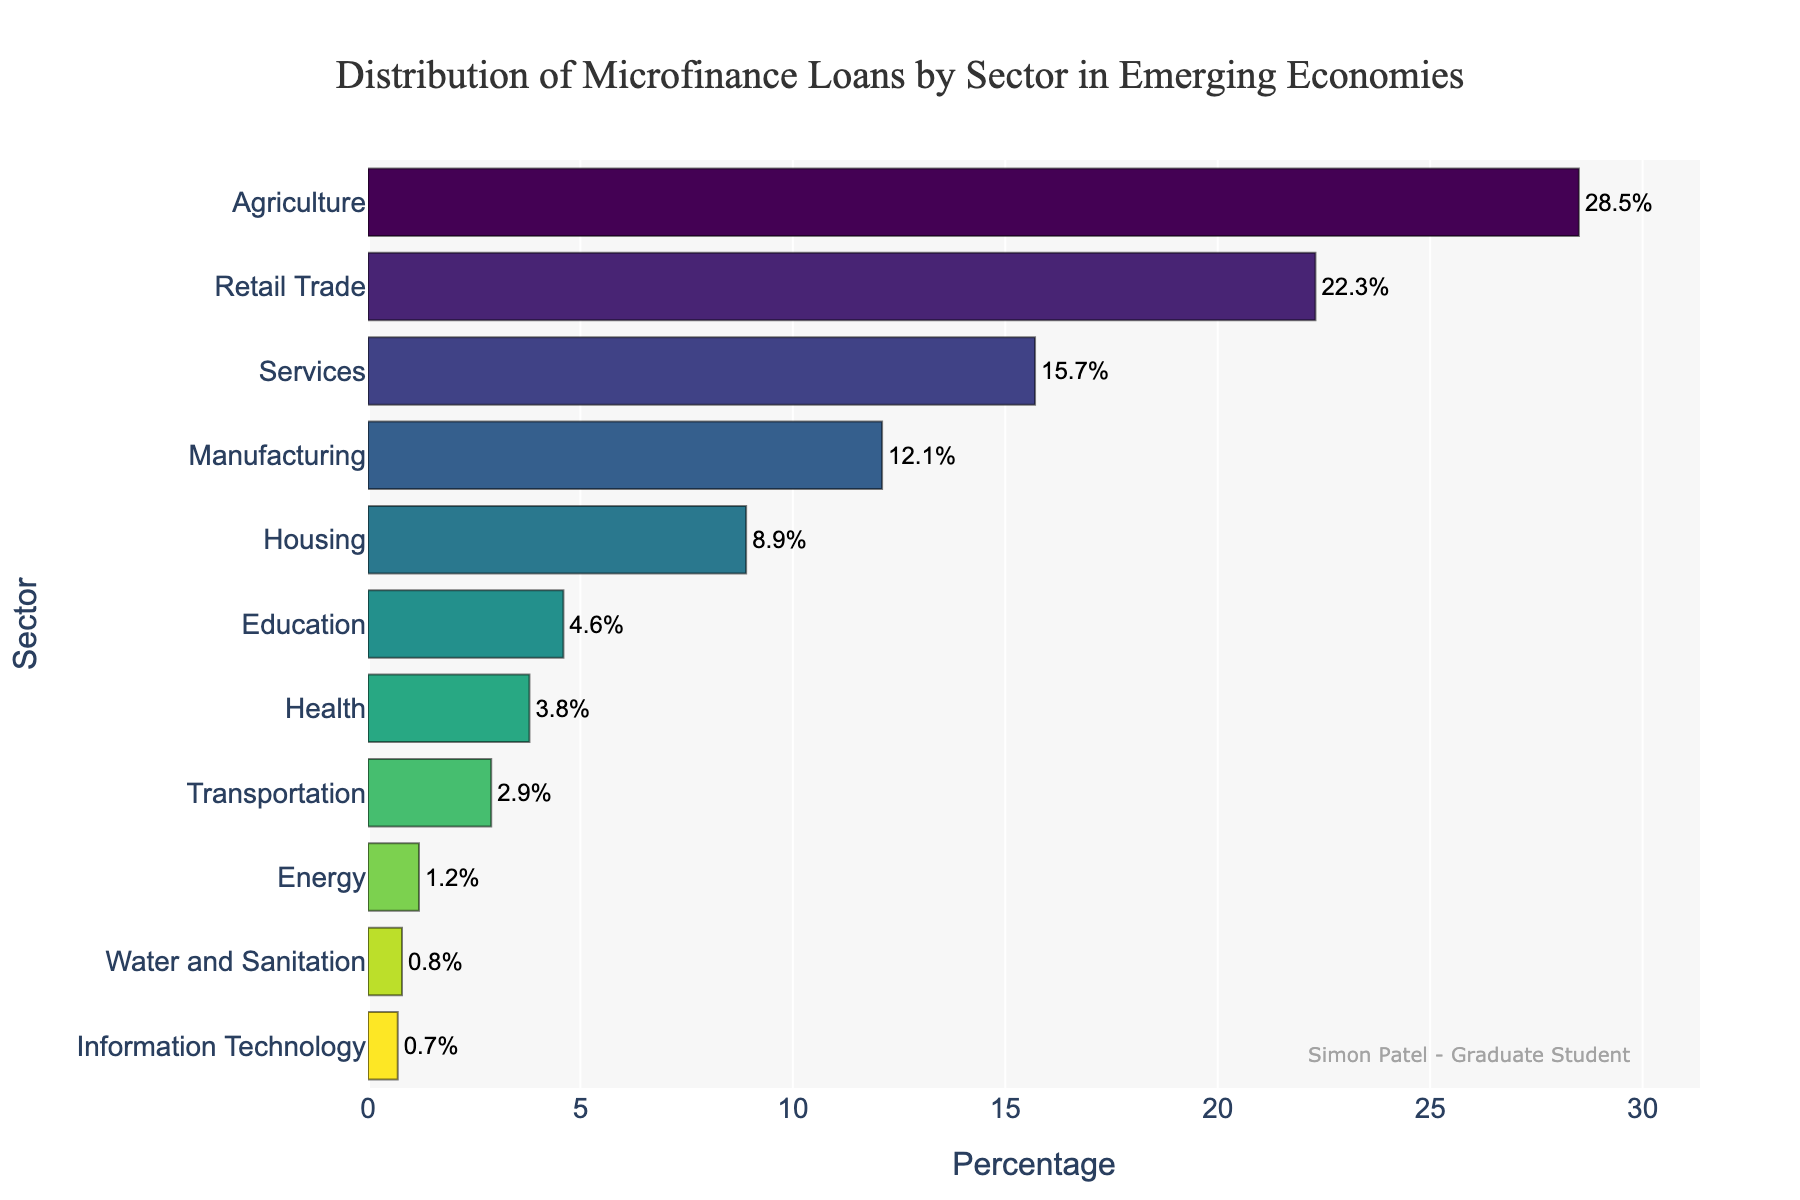Which sector receives the highest percentage of microfinance loans? The highest bar represents Agriculture, with a percentage of 28.5%.
Answer: Agriculture Which sector receives the lowest percentage of microfinance loans? The shortest bar represents Information Technology, with a percentage of 0.7%.
Answer: Information Technology What is the percentage difference between Agriculture and Retail Trade sectors? Agriculture has 28.5% and Retail Trade has 22.3%. The percentage difference is 28.5% - 22.3% = 6.2%.
Answer: 6.2% What are the percentages of the top three sectors in the distribution? The top three sectors are Agriculture (28.5%), Retail Trade (22.3%), and Services (15.7%).
Answer: 28.5%, 22.3%, 15.7% How does the percentage for Manufacturing compare to that of Services? The Manufacturing sector has 12.1% and Services has 15.7%. Manufacturing's percentage is lower than that of Services.
Answer: Lower Which sectors make up the bottom 5 in terms of microfinance loan distribution percentages? The bottom 5 sectors are Health (3.8%), Transportation (2.9%), Energy (1.2%), Water and Sanitation (0.8%), and Information Technology (0.7%).
Answer: Health, Transportation, Energy, Water and Sanitation, Information Technology What is the combined percentage of the Agriculture, Retail Trade, and Services sectors? Sum of Agriculture (28.5%), Retail Trade (22.3%), and Services (15.7%) is 28.5% + 22.3% + 15.7% = 66.5%.
Answer: 66.5% Which sector is allocated around 9% of microfinance loans? The sector with around 9% is Housing, which has 8.9%.
Answer: Housing How much more percentage does the Agriculture sector receive compared to the Housing sector? Agriculture receives 28.5% while Housing receives 8.9%. The difference is 28.5% - 8.9% = 19.6%.
Answer: 19.6% If you add the percentages of Energy, Water and Sanitation, and Information Technology, what is the total? The sum of Energy (1.2%), Water and Sanitation (0.8%), and Information Technology (0.7%) is 1.2% + 0.8% + 0.7% = 2.7%.
Answer: 2.7% 